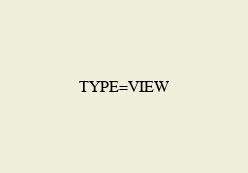Convert code to text. <code><loc_0><loc_0><loc_500><loc_500><_VisualBasic_>TYPE=VIEW</code> 